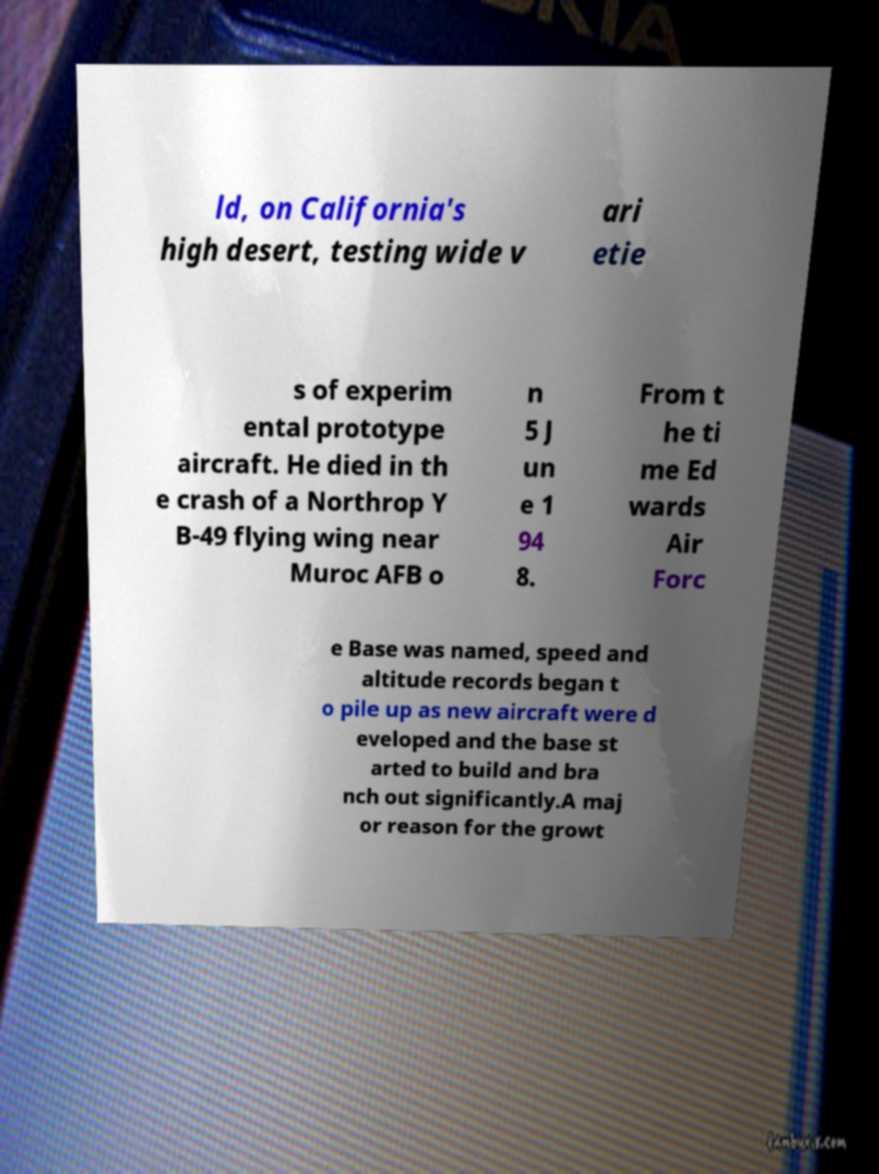There's text embedded in this image that I need extracted. Can you transcribe it verbatim? ld, on California's high desert, testing wide v ari etie s of experim ental prototype aircraft. He died in th e crash of a Northrop Y B-49 flying wing near Muroc AFB o n 5 J un e 1 94 8. From t he ti me Ed wards Air Forc e Base was named, speed and altitude records began t o pile up as new aircraft were d eveloped and the base st arted to build and bra nch out significantly.A maj or reason for the growt 